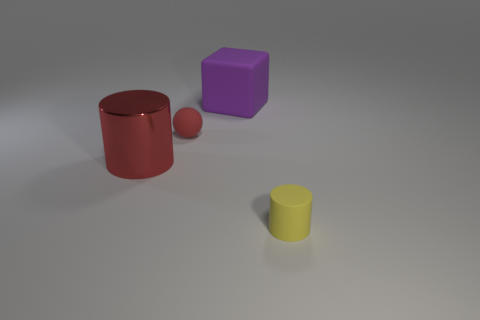Add 2 yellow rubber cylinders. How many objects exist? 6 Subtract all cubes. How many objects are left? 3 Add 2 small red matte spheres. How many small red matte spheres exist? 3 Subtract 0 gray spheres. How many objects are left? 4 Subtract all large things. Subtract all green balls. How many objects are left? 2 Add 4 small balls. How many small balls are left? 5 